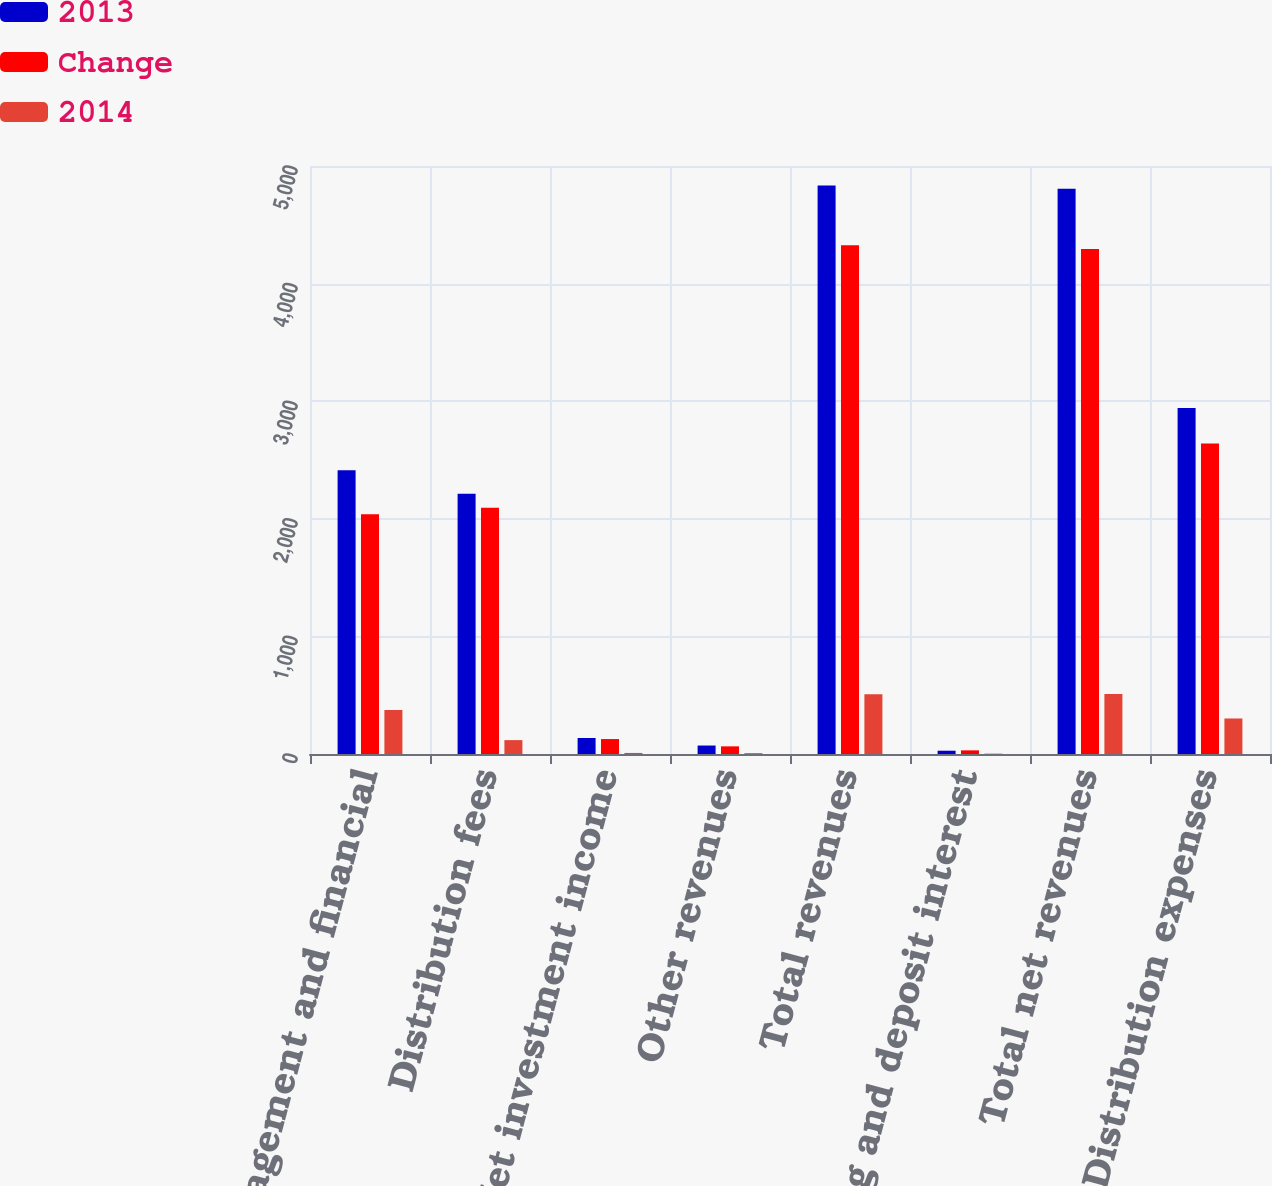Convert chart to OTSL. <chart><loc_0><loc_0><loc_500><loc_500><stacked_bar_chart><ecel><fcel>Management and financial<fcel>Distribution fees<fcel>Net investment income<fcel>Other revenues<fcel>Total revenues<fcel>Banking and deposit interest<fcel>Total net revenues<fcel>Distribution expenses<nl><fcel>2013<fcel>2413<fcel>2213<fcel>136<fcel>72<fcel>4834<fcel>28<fcel>4806<fcel>2943<nl><fcel>Change<fcel>2039<fcel>2095<fcel>127<fcel>65<fcel>4326<fcel>31<fcel>4295<fcel>2641<nl><fcel>2014<fcel>374<fcel>118<fcel>9<fcel>7<fcel>508<fcel>3<fcel>511<fcel>302<nl></chart> 